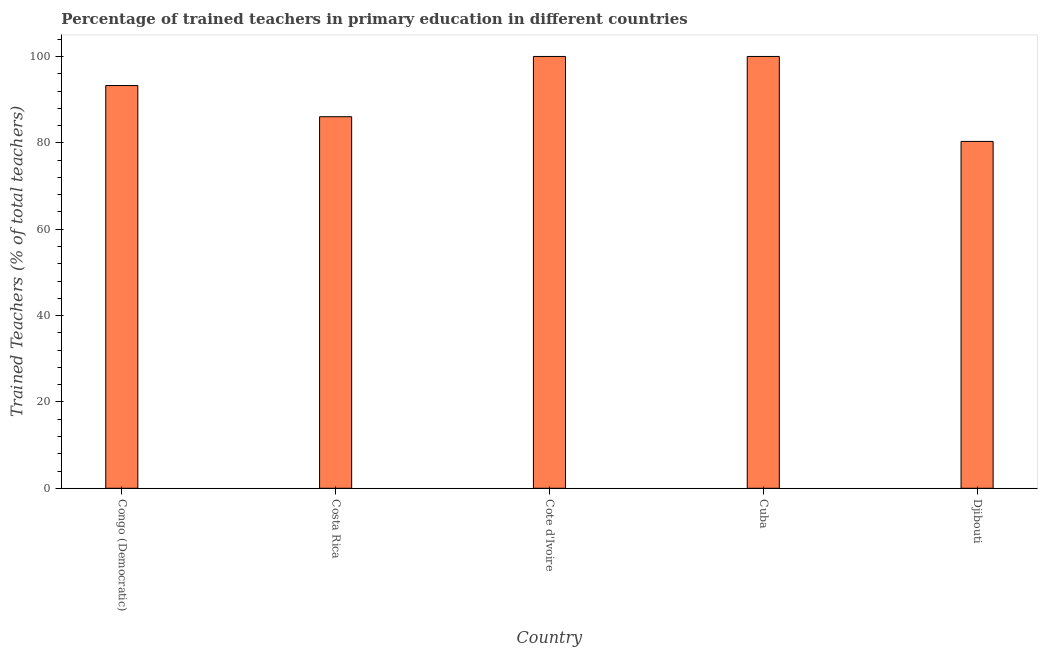Does the graph contain any zero values?
Keep it short and to the point. No. Does the graph contain grids?
Ensure brevity in your answer.  No. What is the title of the graph?
Offer a terse response. Percentage of trained teachers in primary education in different countries. What is the label or title of the X-axis?
Give a very brief answer. Country. What is the label or title of the Y-axis?
Your response must be concise. Trained Teachers (% of total teachers). What is the percentage of trained teachers in Djibouti?
Give a very brief answer. 80.33. Across all countries, what is the minimum percentage of trained teachers?
Provide a short and direct response. 80.33. In which country was the percentage of trained teachers maximum?
Offer a terse response. Cote d'Ivoire. In which country was the percentage of trained teachers minimum?
Give a very brief answer. Djibouti. What is the sum of the percentage of trained teachers?
Keep it short and to the point. 459.64. What is the difference between the percentage of trained teachers in Congo (Democratic) and Cote d'Ivoire?
Your response must be concise. -6.73. What is the average percentage of trained teachers per country?
Offer a terse response. 91.93. What is the median percentage of trained teachers?
Offer a very short reply. 93.27. In how many countries, is the percentage of trained teachers greater than 68 %?
Offer a very short reply. 5. What is the ratio of the percentage of trained teachers in Costa Rica to that in Cuba?
Provide a short and direct response. 0.86. Is the percentage of trained teachers in Cote d'Ivoire less than that in Djibouti?
Your answer should be very brief. No. Is the sum of the percentage of trained teachers in Congo (Democratic) and Costa Rica greater than the maximum percentage of trained teachers across all countries?
Your response must be concise. Yes. What is the difference between the highest and the lowest percentage of trained teachers?
Give a very brief answer. 19.67. In how many countries, is the percentage of trained teachers greater than the average percentage of trained teachers taken over all countries?
Offer a terse response. 3. What is the Trained Teachers (% of total teachers) of Congo (Democratic)?
Provide a short and direct response. 93.27. What is the Trained Teachers (% of total teachers) of Costa Rica?
Your answer should be very brief. 86.05. What is the Trained Teachers (% of total teachers) in Cote d'Ivoire?
Your answer should be very brief. 100. What is the Trained Teachers (% of total teachers) in Djibouti?
Ensure brevity in your answer.  80.33. What is the difference between the Trained Teachers (% of total teachers) in Congo (Democratic) and Costa Rica?
Your answer should be compact. 7.22. What is the difference between the Trained Teachers (% of total teachers) in Congo (Democratic) and Cote d'Ivoire?
Provide a short and direct response. -6.73. What is the difference between the Trained Teachers (% of total teachers) in Congo (Democratic) and Cuba?
Give a very brief answer. -6.73. What is the difference between the Trained Teachers (% of total teachers) in Congo (Democratic) and Djibouti?
Provide a succinct answer. 12.94. What is the difference between the Trained Teachers (% of total teachers) in Costa Rica and Cote d'Ivoire?
Make the answer very short. -13.95. What is the difference between the Trained Teachers (% of total teachers) in Costa Rica and Cuba?
Provide a succinct answer. -13.95. What is the difference between the Trained Teachers (% of total teachers) in Costa Rica and Djibouti?
Give a very brief answer. 5.72. What is the difference between the Trained Teachers (% of total teachers) in Cote d'Ivoire and Djibouti?
Offer a terse response. 19.67. What is the difference between the Trained Teachers (% of total teachers) in Cuba and Djibouti?
Offer a terse response. 19.67. What is the ratio of the Trained Teachers (% of total teachers) in Congo (Democratic) to that in Costa Rica?
Your answer should be very brief. 1.08. What is the ratio of the Trained Teachers (% of total teachers) in Congo (Democratic) to that in Cote d'Ivoire?
Offer a very short reply. 0.93. What is the ratio of the Trained Teachers (% of total teachers) in Congo (Democratic) to that in Cuba?
Offer a terse response. 0.93. What is the ratio of the Trained Teachers (% of total teachers) in Congo (Democratic) to that in Djibouti?
Keep it short and to the point. 1.16. What is the ratio of the Trained Teachers (% of total teachers) in Costa Rica to that in Cote d'Ivoire?
Keep it short and to the point. 0.86. What is the ratio of the Trained Teachers (% of total teachers) in Costa Rica to that in Cuba?
Offer a very short reply. 0.86. What is the ratio of the Trained Teachers (% of total teachers) in Costa Rica to that in Djibouti?
Offer a very short reply. 1.07. What is the ratio of the Trained Teachers (% of total teachers) in Cote d'Ivoire to that in Djibouti?
Make the answer very short. 1.25. What is the ratio of the Trained Teachers (% of total teachers) in Cuba to that in Djibouti?
Your answer should be compact. 1.25. 